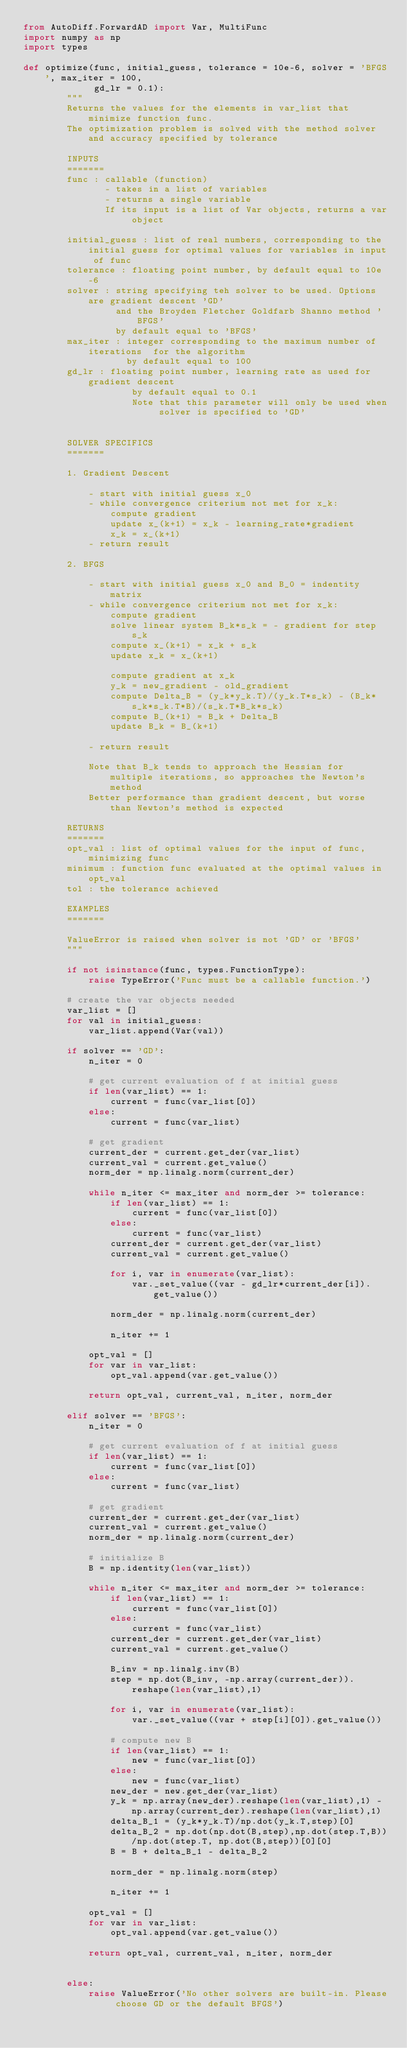Convert code to text. <code><loc_0><loc_0><loc_500><loc_500><_Python_>from AutoDiff.ForwardAD import Var, MultiFunc
import numpy as np
import types

def optimize(func, initial_guess, tolerance = 10e-6, solver = 'BFGS', max_iter = 100,
             gd_lr = 0.1):
        """
        Returns the values for the elements in var_list that minimize function func.
        The optimization problem is solved with the method solver and accuracy specified by tolerance

        INPUTS
        =======
        func : callable (function)
               - takes in a list of variables
               - returns a single variable
               If its input is a list of Var objects, returns a var object

        initial_guess : list of real numbers, corresponding to the initial guess for optimal values for variables in input of func
        tolerance : floating point number, by default equal to 10e-6
        solver : string specifying teh solver to be used. Options are gradient descent 'GD'
                 and the Broyden Fletcher Goldfarb Shanno method 'BFGS'
                 by default equal to 'BFGS'
        max_iter : integer corresponding to the maximum number of iterations  for the algorithm
                   by default equal to 100
        gd_lr : floating point number, learning rate as used for gradient descent
                    by default equal to 0.1
                    Note that this parameter will only be used when solver is specified to 'GD'


        SOLVER SPECIFICS
        =======

        1. Gradient Descent

            - start with initial guess x_0
            - while convergence criterium not met for x_k:
                compute gradient
                update x_(k+1) = x_k - learning_rate*gradient
                x_k = x_(k+1)
            - return result

        2. BFGS

            - start with initial guess x_0 and B_0 = indentity matrix
            - while convergence criterium not met for x_k:
                compute gradient
                solve linear system B_k*s_k = - gradient for step s_k
                compute x_(k+1) = x_k + s_k
                update x_k = x_(k+1)

                compute gradient at x_k
                y_k = new_gradient - old_gradient
                compute Delta_B = (y_k*y_k.T)/(y_k.T*s_k) - (B_k*s_k*s_k.T*B)/(s_k.T*B_k*s_k)
                compute B_(k+1) = B_k + Delta_B
                update B_k = B_(k+1)

            - return result

            Note that B_k tends to approach the Hessian for multiple iterations, so approaches the Newton's method
            Better performance than gradient descent, but worse than Newton's method is expected

        RETURNS
        =======
        opt_val : list of optimal values for the input of func, minimizing func
        minimum : function func evaluated at the optimal values in opt_val
        tol : the tolerance achieved

        EXAMPLES
        =======

        ValueError is raised when solver is not 'GD' or 'BFGS'
        """

        if not isinstance(func, types.FunctionType):
            raise TypeError('Func must be a callable function.')

        # create the var objects needed
        var_list = []
        for val in initial_guess:
            var_list.append(Var(val))

        if solver == 'GD':
            n_iter = 0

            # get current evaluation of f at initial guess
            if len(var_list) == 1:
                current = func(var_list[0])
            else:
                current = func(var_list)

            # get gradient
            current_der = current.get_der(var_list)
            current_val = current.get_value()
            norm_der = np.linalg.norm(current_der)

            while n_iter <= max_iter and norm_der >= tolerance:
                if len(var_list) == 1:
                    current = func(var_list[0])
                else:
                    current = func(var_list)
                current_der = current.get_der(var_list)
                current_val = current.get_value()

                for i, var in enumerate(var_list):
                    var._set_value((var - gd_lr*current_der[i]).get_value())

                norm_der = np.linalg.norm(current_der)

                n_iter += 1

            opt_val = []
            for var in var_list:
                opt_val.append(var.get_value())

            return opt_val, current_val, n_iter, norm_der

        elif solver == 'BFGS':
            n_iter = 0

            # get current evaluation of f at initial guess
            if len(var_list) == 1:
                current = func(var_list[0])
            else:
                current = func(var_list)

            # get gradient
            current_der = current.get_der(var_list)
            current_val = current.get_value()
            norm_der = np.linalg.norm(current_der)

            # initialize B
            B = np.identity(len(var_list))

            while n_iter <= max_iter and norm_der >= tolerance:
                if len(var_list) == 1:
                    current = func(var_list[0])
                else:
                    current = func(var_list)
                current_der = current.get_der(var_list)
                current_val = current.get_value()

                B_inv = np.linalg.inv(B)
                step = np.dot(B_inv, -np.array(current_der)).reshape(len(var_list),1)

                for i, var in enumerate(var_list):
                    var._set_value((var + step[i][0]).get_value())

                # compute new B
                if len(var_list) == 1:
                    new = func(var_list[0])
                else:
                    new = func(var_list)
                new_der = new.get_der(var_list)
                y_k = np.array(new_der).reshape(len(var_list),1) - np.array(current_der).reshape(len(var_list),1)
                delta_B_1 = (y_k*y_k.T)/np.dot(y_k.T,step)[0]
                delta_B_2 = np.dot(np.dot(B,step),np.dot(step.T,B))/np.dot(step.T, np.dot(B,step))[0][0]
                B = B + delta_B_1 - delta_B_2

                norm_der = np.linalg.norm(step)

                n_iter += 1

            opt_val = []
            for var in var_list:
                opt_val.append(var.get_value())

            return opt_val, current_val, n_iter, norm_der


        else:
            raise ValueError('No other solvers are built-in. Please choose GD or the default BFGS')

</code> 